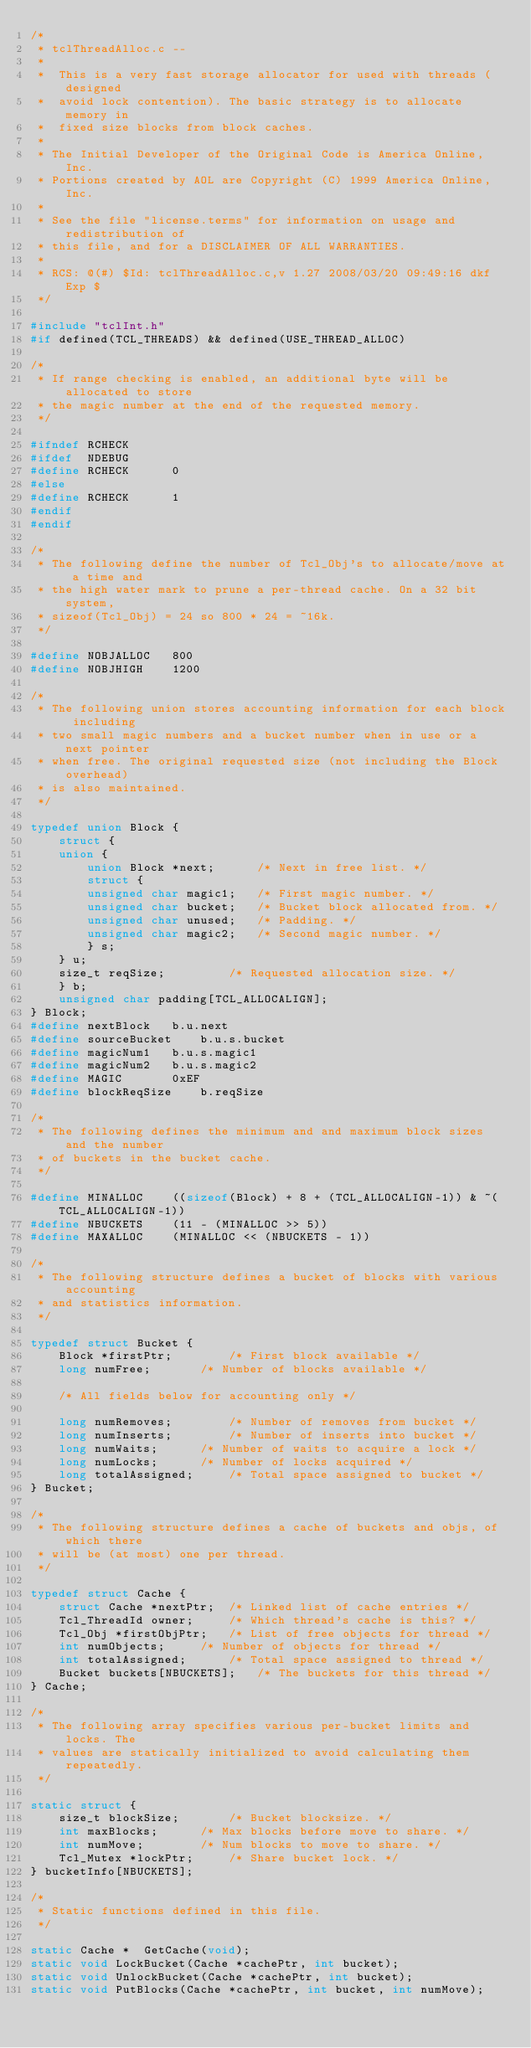<code> <loc_0><loc_0><loc_500><loc_500><_C_>/*
 * tclThreadAlloc.c --
 *
 *	This is a very fast storage allocator for used with threads (designed
 *	avoid lock contention). The basic strategy is to allocate memory in
 *	fixed size blocks from block caches.
 *
 * The Initial Developer of the Original Code is America Online, Inc.
 * Portions created by AOL are Copyright (C) 1999 America Online, Inc.
 *
 * See the file "license.terms" for information on usage and redistribution of
 * this file, and for a DISCLAIMER OF ALL WARRANTIES.
 *
 * RCS: @(#) $Id: tclThreadAlloc.c,v 1.27 2008/03/20 09:49:16 dkf Exp $
 */

#include "tclInt.h"
#if defined(TCL_THREADS) && defined(USE_THREAD_ALLOC)

/*
 * If range checking is enabled, an additional byte will be allocated to store
 * the magic number at the end of the requested memory.
 */

#ifndef RCHECK
#ifdef  NDEBUG
#define RCHECK		0
#else
#define RCHECK		1
#endif
#endif

/*
 * The following define the number of Tcl_Obj's to allocate/move at a time and
 * the high water mark to prune a per-thread cache. On a 32 bit system,
 * sizeof(Tcl_Obj) = 24 so 800 * 24 = ~16k.
 */

#define NOBJALLOC	800
#define NOBJHIGH	1200

/*
 * The following union stores accounting information for each block including
 * two small magic numbers and a bucket number when in use or a next pointer
 * when free. The original requested size (not including the Block overhead)
 * is also maintained.
 */

typedef union Block {
    struct {
	union {
	    union Block *next;		/* Next in free list. */
	    struct {
		unsigned char magic1;	/* First magic number. */
		unsigned char bucket;	/* Bucket block allocated from. */
		unsigned char unused;	/* Padding. */
		unsigned char magic2;	/* Second magic number. */
	    } s;
	} u;
	size_t reqSize;			/* Requested allocation size. */
    } b;
    unsigned char padding[TCL_ALLOCALIGN];
} Block;
#define nextBlock	b.u.next
#define sourceBucket	b.u.s.bucket
#define magicNum1	b.u.s.magic1
#define magicNum2	b.u.s.magic2
#define MAGIC		0xEF
#define blockReqSize	b.reqSize

/*
 * The following defines the minimum and and maximum block sizes and the number
 * of buckets in the bucket cache.
 */

#define MINALLOC	((sizeof(Block) + 8 + (TCL_ALLOCALIGN-1)) & ~(TCL_ALLOCALIGN-1))
#define NBUCKETS	(11 - (MINALLOC >> 5))
#define MAXALLOC	(MINALLOC << (NBUCKETS - 1))

/*
 * The following structure defines a bucket of blocks with various accounting
 * and statistics information.
 */

typedef struct Bucket {
    Block *firstPtr;		/* First block available */
    long numFree;		/* Number of blocks available */

    /* All fields below for accounting only */

    long numRemoves;		/* Number of removes from bucket */
    long numInserts;		/* Number of inserts into bucket */
    long numWaits;		/* Number of waits to acquire a lock */
    long numLocks;		/* Number of locks acquired */
    long totalAssigned;		/* Total space assigned to bucket */
} Bucket;

/*
 * The following structure defines a cache of buckets and objs, of which there
 * will be (at most) one per thread.
 */

typedef struct Cache {
    struct Cache *nextPtr;	/* Linked list of cache entries */
    Tcl_ThreadId owner;		/* Which thread's cache is this? */
    Tcl_Obj *firstObjPtr;	/* List of free objects for thread */
    int numObjects;		/* Number of objects for thread */
    int totalAssigned;		/* Total space assigned to thread */
    Bucket buckets[NBUCKETS];	/* The buckets for this thread */
} Cache;

/*
 * The following array specifies various per-bucket limits and locks. The
 * values are statically initialized to avoid calculating them repeatedly.
 */

static struct {
    size_t blockSize;		/* Bucket blocksize. */
    int maxBlocks;		/* Max blocks before move to share. */
    int numMove;		/* Num blocks to move to share. */
    Tcl_Mutex *lockPtr;		/* Share bucket lock. */
} bucketInfo[NBUCKETS];

/*
 * Static functions defined in this file.
 */

static Cache *	GetCache(void);
static void	LockBucket(Cache *cachePtr, int bucket);
static void	UnlockBucket(Cache *cachePtr, int bucket);
static void	PutBlocks(Cache *cachePtr, int bucket, int numMove);</code> 